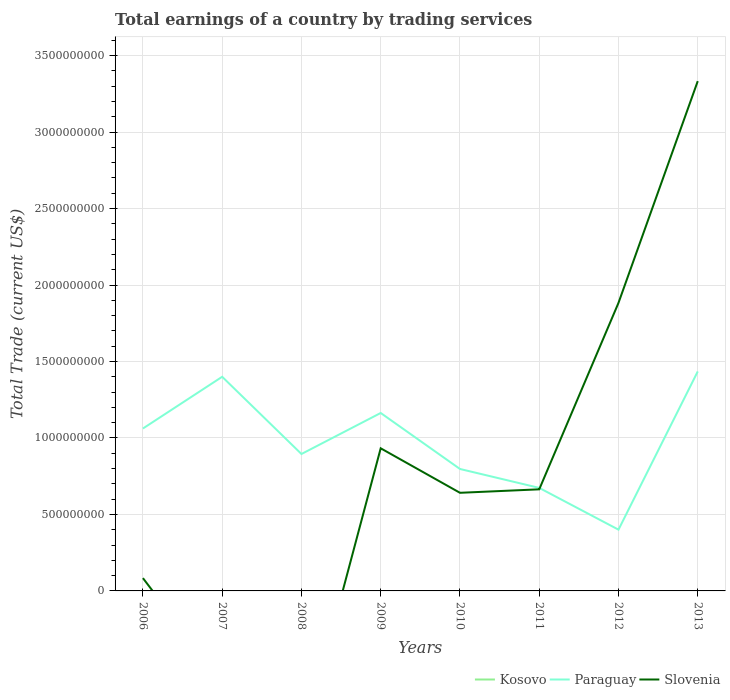Is the number of lines equal to the number of legend labels?
Your answer should be very brief. No. Across all years, what is the maximum total earnings in Kosovo?
Make the answer very short. 0. What is the total total earnings in Paraguay in the graph?
Your answer should be very brief. 6.61e+08. What is the difference between the highest and the second highest total earnings in Paraguay?
Provide a short and direct response. 1.03e+09. How many lines are there?
Make the answer very short. 2. How many years are there in the graph?
Make the answer very short. 8. What is the difference between two consecutive major ticks on the Y-axis?
Your answer should be compact. 5.00e+08. Are the values on the major ticks of Y-axis written in scientific E-notation?
Keep it short and to the point. No. Does the graph contain any zero values?
Make the answer very short. Yes. Does the graph contain grids?
Your answer should be very brief. Yes. Where does the legend appear in the graph?
Provide a short and direct response. Bottom right. What is the title of the graph?
Keep it short and to the point. Total earnings of a country by trading services. Does "Pakistan" appear as one of the legend labels in the graph?
Your answer should be compact. No. What is the label or title of the X-axis?
Provide a short and direct response. Years. What is the label or title of the Y-axis?
Ensure brevity in your answer.  Total Trade (current US$). What is the Total Trade (current US$) in Kosovo in 2006?
Offer a very short reply. 0. What is the Total Trade (current US$) in Paraguay in 2006?
Ensure brevity in your answer.  1.06e+09. What is the Total Trade (current US$) of Slovenia in 2006?
Give a very brief answer. 8.38e+07. What is the Total Trade (current US$) of Paraguay in 2007?
Offer a very short reply. 1.40e+09. What is the Total Trade (current US$) of Slovenia in 2007?
Ensure brevity in your answer.  0. What is the Total Trade (current US$) of Paraguay in 2008?
Your answer should be compact. 8.95e+08. What is the Total Trade (current US$) of Slovenia in 2008?
Provide a succinct answer. 0. What is the Total Trade (current US$) in Kosovo in 2009?
Provide a succinct answer. 0. What is the Total Trade (current US$) of Paraguay in 2009?
Provide a short and direct response. 1.16e+09. What is the Total Trade (current US$) in Slovenia in 2009?
Make the answer very short. 9.32e+08. What is the Total Trade (current US$) of Paraguay in 2010?
Offer a very short reply. 7.97e+08. What is the Total Trade (current US$) of Slovenia in 2010?
Your answer should be compact. 6.42e+08. What is the Total Trade (current US$) of Kosovo in 2011?
Keep it short and to the point. 0. What is the Total Trade (current US$) in Paraguay in 2011?
Provide a short and direct response. 6.74e+08. What is the Total Trade (current US$) of Slovenia in 2011?
Keep it short and to the point. 6.64e+08. What is the Total Trade (current US$) of Paraguay in 2012?
Your response must be concise. 4.01e+08. What is the Total Trade (current US$) of Slovenia in 2012?
Provide a short and direct response. 1.88e+09. What is the Total Trade (current US$) of Kosovo in 2013?
Provide a short and direct response. 0. What is the Total Trade (current US$) in Paraguay in 2013?
Provide a short and direct response. 1.43e+09. What is the Total Trade (current US$) of Slovenia in 2013?
Provide a succinct answer. 3.33e+09. Across all years, what is the maximum Total Trade (current US$) of Paraguay?
Your answer should be compact. 1.43e+09. Across all years, what is the maximum Total Trade (current US$) in Slovenia?
Keep it short and to the point. 3.33e+09. Across all years, what is the minimum Total Trade (current US$) in Paraguay?
Your response must be concise. 4.01e+08. Across all years, what is the minimum Total Trade (current US$) of Slovenia?
Provide a short and direct response. 0. What is the total Total Trade (current US$) of Paraguay in the graph?
Provide a succinct answer. 7.83e+09. What is the total Total Trade (current US$) in Slovenia in the graph?
Make the answer very short. 7.54e+09. What is the difference between the Total Trade (current US$) in Paraguay in 2006 and that in 2007?
Keep it short and to the point. -3.38e+08. What is the difference between the Total Trade (current US$) in Paraguay in 2006 and that in 2008?
Offer a terse response. 1.67e+08. What is the difference between the Total Trade (current US$) of Paraguay in 2006 and that in 2009?
Your answer should be compact. -1.02e+08. What is the difference between the Total Trade (current US$) of Slovenia in 2006 and that in 2009?
Provide a short and direct response. -8.49e+08. What is the difference between the Total Trade (current US$) of Paraguay in 2006 and that in 2010?
Your answer should be very brief. 2.65e+08. What is the difference between the Total Trade (current US$) of Slovenia in 2006 and that in 2010?
Your answer should be very brief. -5.58e+08. What is the difference between the Total Trade (current US$) in Paraguay in 2006 and that in 2011?
Provide a succinct answer. 3.88e+08. What is the difference between the Total Trade (current US$) in Slovenia in 2006 and that in 2011?
Keep it short and to the point. -5.80e+08. What is the difference between the Total Trade (current US$) in Paraguay in 2006 and that in 2012?
Your answer should be very brief. 6.61e+08. What is the difference between the Total Trade (current US$) of Slovenia in 2006 and that in 2012?
Ensure brevity in your answer.  -1.80e+09. What is the difference between the Total Trade (current US$) in Paraguay in 2006 and that in 2013?
Your response must be concise. -3.73e+08. What is the difference between the Total Trade (current US$) in Slovenia in 2006 and that in 2013?
Your answer should be very brief. -3.25e+09. What is the difference between the Total Trade (current US$) in Paraguay in 2007 and that in 2008?
Provide a short and direct response. 5.05e+08. What is the difference between the Total Trade (current US$) in Paraguay in 2007 and that in 2009?
Offer a very short reply. 2.37e+08. What is the difference between the Total Trade (current US$) of Paraguay in 2007 and that in 2010?
Keep it short and to the point. 6.03e+08. What is the difference between the Total Trade (current US$) in Paraguay in 2007 and that in 2011?
Your answer should be compact. 7.26e+08. What is the difference between the Total Trade (current US$) in Paraguay in 2007 and that in 2012?
Give a very brief answer. 1.00e+09. What is the difference between the Total Trade (current US$) in Paraguay in 2007 and that in 2013?
Provide a short and direct response. -3.49e+07. What is the difference between the Total Trade (current US$) of Paraguay in 2008 and that in 2009?
Your answer should be very brief. -2.68e+08. What is the difference between the Total Trade (current US$) of Paraguay in 2008 and that in 2010?
Give a very brief answer. 9.79e+07. What is the difference between the Total Trade (current US$) of Paraguay in 2008 and that in 2011?
Make the answer very short. 2.22e+08. What is the difference between the Total Trade (current US$) of Paraguay in 2008 and that in 2012?
Provide a short and direct response. 4.95e+08. What is the difference between the Total Trade (current US$) of Paraguay in 2008 and that in 2013?
Offer a very short reply. -5.40e+08. What is the difference between the Total Trade (current US$) of Paraguay in 2009 and that in 2010?
Offer a terse response. 3.66e+08. What is the difference between the Total Trade (current US$) in Slovenia in 2009 and that in 2010?
Provide a succinct answer. 2.91e+08. What is the difference between the Total Trade (current US$) of Paraguay in 2009 and that in 2011?
Your answer should be very brief. 4.90e+08. What is the difference between the Total Trade (current US$) in Slovenia in 2009 and that in 2011?
Provide a short and direct response. 2.68e+08. What is the difference between the Total Trade (current US$) in Paraguay in 2009 and that in 2012?
Give a very brief answer. 7.63e+08. What is the difference between the Total Trade (current US$) of Slovenia in 2009 and that in 2012?
Your response must be concise. -9.51e+08. What is the difference between the Total Trade (current US$) in Paraguay in 2009 and that in 2013?
Offer a terse response. -2.72e+08. What is the difference between the Total Trade (current US$) of Slovenia in 2009 and that in 2013?
Make the answer very short. -2.40e+09. What is the difference between the Total Trade (current US$) in Paraguay in 2010 and that in 2011?
Provide a short and direct response. 1.24e+08. What is the difference between the Total Trade (current US$) of Slovenia in 2010 and that in 2011?
Offer a very short reply. -2.27e+07. What is the difference between the Total Trade (current US$) of Paraguay in 2010 and that in 2012?
Your answer should be very brief. 3.97e+08. What is the difference between the Total Trade (current US$) of Slovenia in 2010 and that in 2012?
Provide a succinct answer. -1.24e+09. What is the difference between the Total Trade (current US$) of Paraguay in 2010 and that in 2013?
Your response must be concise. -6.38e+08. What is the difference between the Total Trade (current US$) in Slovenia in 2010 and that in 2013?
Provide a short and direct response. -2.69e+09. What is the difference between the Total Trade (current US$) in Paraguay in 2011 and that in 2012?
Offer a terse response. 2.73e+08. What is the difference between the Total Trade (current US$) in Slovenia in 2011 and that in 2012?
Your answer should be compact. -1.22e+09. What is the difference between the Total Trade (current US$) in Paraguay in 2011 and that in 2013?
Keep it short and to the point. -7.61e+08. What is the difference between the Total Trade (current US$) in Slovenia in 2011 and that in 2013?
Make the answer very short. -2.67e+09. What is the difference between the Total Trade (current US$) of Paraguay in 2012 and that in 2013?
Make the answer very short. -1.03e+09. What is the difference between the Total Trade (current US$) in Slovenia in 2012 and that in 2013?
Your answer should be compact. -1.45e+09. What is the difference between the Total Trade (current US$) in Paraguay in 2006 and the Total Trade (current US$) in Slovenia in 2009?
Your answer should be very brief. 1.29e+08. What is the difference between the Total Trade (current US$) in Paraguay in 2006 and the Total Trade (current US$) in Slovenia in 2010?
Your answer should be compact. 4.20e+08. What is the difference between the Total Trade (current US$) of Paraguay in 2006 and the Total Trade (current US$) of Slovenia in 2011?
Keep it short and to the point. 3.98e+08. What is the difference between the Total Trade (current US$) in Paraguay in 2006 and the Total Trade (current US$) in Slovenia in 2012?
Offer a very short reply. -8.22e+08. What is the difference between the Total Trade (current US$) of Paraguay in 2006 and the Total Trade (current US$) of Slovenia in 2013?
Offer a very short reply. -2.27e+09. What is the difference between the Total Trade (current US$) in Paraguay in 2007 and the Total Trade (current US$) in Slovenia in 2009?
Your response must be concise. 4.68e+08. What is the difference between the Total Trade (current US$) of Paraguay in 2007 and the Total Trade (current US$) of Slovenia in 2010?
Offer a terse response. 7.59e+08. What is the difference between the Total Trade (current US$) in Paraguay in 2007 and the Total Trade (current US$) in Slovenia in 2011?
Ensure brevity in your answer.  7.36e+08. What is the difference between the Total Trade (current US$) of Paraguay in 2007 and the Total Trade (current US$) of Slovenia in 2012?
Make the answer very short. -4.83e+08. What is the difference between the Total Trade (current US$) of Paraguay in 2007 and the Total Trade (current US$) of Slovenia in 2013?
Offer a terse response. -1.93e+09. What is the difference between the Total Trade (current US$) of Paraguay in 2008 and the Total Trade (current US$) of Slovenia in 2009?
Provide a short and direct response. -3.73e+07. What is the difference between the Total Trade (current US$) in Paraguay in 2008 and the Total Trade (current US$) in Slovenia in 2010?
Give a very brief answer. 2.54e+08. What is the difference between the Total Trade (current US$) of Paraguay in 2008 and the Total Trade (current US$) of Slovenia in 2011?
Offer a terse response. 2.31e+08. What is the difference between the Total Trade (current US$) in Paraguay in 2008 and the Total Trade (current US$) in Slovenia in 2012?
Offer a very short reply. -9.88e+08. What is the difference between the Total Trade (current US$) of Paraguay in 2008 and the Total Trade (current US$) of Slovenia in 2013?
Make the answer very short. -2.44e+09. What is the difference between the Total Trade (current US$) of Paraguay in 2009 and the Total Trade (current US$) of Slovenia in 2010?
Provide a short and direct response. 5.22e+08. What is the difference between the Total Trade (current US$) of Paraguay in 2009 and the Total Trade (current US$) of Slovenia in 2011?
Your answer should be very brief. 4.99e+08. What is the difference between the Total Trade (current US$) of Paraguay in 2009 and the Total Trade (current US$) of Slovenia in 2012?
Offer a very short reply. -7.20e+08. What is the difference between the Total Trade (current US$) of Paraguay in 2009 and the Total Trade (current US$) of Slovenia in 2013?
Offer a very short reply. -2.17e+09. What is the difference between the Total Trade (current US$) of Paraguay in 2010 and the Total Trade (current US$) of Slovenia in 2011?
Offer a very short reply. 1.33e+08. What is the difference between the Total Trade (current US$) in Paraguay in 2010 and the Total Trade (current US$) in Slovenia in 2012?
Provide a short and direct response. -1.09e+09. What is the difference between the Total Trade (current US$) in Paraguay in 2010 and the Total Trade (current US$) in Slovenia in 2013?
Provide a short and direct response. -2.54e+09. What is the difference between the Total Trade (current US$) in Paraguay in 2011 and the Total Trade (current US$) in Slovenia in 2012?
Your response must be concise. -1.21e+09. What is the difference between the Total Trade (current US$) of Paraguay in 2011 and the Total Trade (current US$) of Slovenia in 2013?
Provide a succinct answer. -2.66e+09. What is the difference between the Total Trade (current US$) of Paraguay in 2012 and the Total Trade (current US$) of Slovenia in 2013?
Keep it short and to the point. -2.93e+09. What is the average Total Trade (current US$) of Kosovo per year?
Make the answer very short. 0. What is the average Total Trade (current US$) in Paraguay per year?
Your answer should be compact. 9.78e+08. What is the average Total Trade (current US$) in Slovenia per year?
Offer a terse response. 9.42e+08. In the year 2006, what is the difference between the Total Trade (current US$) of Paraguay and Total Trade (current US$) of Slovenia?
Provide a short and direct response. 9.78e+08. In the year 2009, what is the difference between the Total Trade (current US$) of Paraguay and Total Trade (current US$) of Slovenia?
Ensure brevity in your answer.  2.31e+08. In the year 2010, what is the difference between the Total Trade (current US$) in Paraguay and Total Trade (current US$) in Slovenia?
Your answer should be very brief. 1.56e+08. In the year 2011, what is the difference between the Total Trade (current US$) of Paraguay and Total Trade (current US$) of Slovenia?
Your answer should be compact. 9.43e+06. In the year 2012, what is the difference between the Total Trade (current US$) of Paraguay and Total Trade (current US$) of Slovenia?
Ensure brevity in your answer.  -1.48e+09. In the year 2013, what is the difference between the Total Trade (current US$) in Paraguay and Total Trade (current US$) in Slovenia?
Give a very brief answer. -1.90e+09. What is the ratio of the Total Trade (current US$) of Paraguay in 2006 to that in 2007?
Provide a succinct answer. 0.76. What is the ratio of the Total Trade (current US$) in Paraguay in 2006 to that in 2008?
Give a very brief answer. 1.19. What is the ratio of the Total Trade (current US$) in Paraguay in 2006 to that in 2009?
Offer a terse response. 0.91. What is the ratio of the Total Trade (current US$) in Slovenia in 2006 to that in 2009?
Your answer should be compact. 0.09. What is the ratio of the Total Trade (current US$) in Paraguay in 2006 to that in 2010?
Your answer should be compact. 1.33. What is the ratio of the Total Trade (current US$) of Slovenia in 2006 to that in 2010?
Your answer should be compact. 0.13. What is the ratio of the Total Trade (current US$) of Paraguay in 2006 to that in 2011?
Make the answer very short. 1.58. What is the ratio of the Total Trade (current US$) of Slovenia in 2006 to that in 2011?
Your answer should be very brief. 0.13. What is the ratio of the Total Trade (current US$) of Paraguay in 2006 to that in 2012?
Keep it short and to the point. 2.65. What is the ratio of the Total Trade (current US$) of Slovenia in 2006 to that in 2012?
Provide a succinct answer. 0.04. What is the ratio of the Total Trade (current US$) of Paraguay in 2006 to that in 2013?
Provide a succinct answer. 0.74. What is the ratio of the Total Trade (current US$) of Slovenia in 2006 to that in 2013?
Offer a very short reply. 0.03. What is the ratio of the Total Trade (current US$) in Paraguay in 2007 to that in 2008?
Your answer should be very brief. 1.56. What is the ratio of the Total Trade (current US$) in Paraguay in 2007 to that in 2009?
Offer a very short reply. 1.2. What is the ratio of the Total Trade (current US$) in Paraguay in 2007 to that in 2010?
Ensure brevity in your answer.  1.76. What is the ratio of the Total Trade (current US$) of Paraguay in 2007 to that in 2011?
Make the answer very short. 2.08. What is the ratio of the Total Trade (current US$) in Paraguay in 2007 to that in 2012?
Your answer should be very brief. 3.5. What is the ratio of the Total Trade (current US$) of Paraguay in 2007 to that in 2013?
Give a very brief answer. 0.98. What is the ratio of the Total Trade (current US$) in Paraguay in 2008 to that in 2009?
Offer a very short reply. 0.77. What is the ratio of the Total Trade (current US$) in Paraguay in 2008 to that in 2010?
Make the answer very short. 1.12. What is the ratio of the Total Trade (current US$) of Paraguay in 2008 to that in 2011?
Ensure brevity in your answer.  1.33. What is the ratio of the Total Trade (current US$) of Paraguay in 2008 to that in 2012?
Offer a terse response. 2.23. What is the ratio of the Total Trade (current US$) in Paraguay in 2008 to that in 2013?
Your response must be concise. 0.62. What is the ratio of the Total Trade (current US$) of Paraguay in 2009 to that in 2010?
Offer a terse response. 1.46. What is the ratio of the Total Trade (current US$) of Slovenia in 2009 to that in 2010?
Your response must be concise. 1.45. What is the ratio of the Total Trade (current US$) of Paraguay in 2009 to that in 2011?
Your response must be concise. 1.73. What is the ratio of the Total Trade (current US$) in Slovenia in 2009 to that in 2011?
Ensure brevity in your answer.  1.4. What is the ratio of the Total Trade (current US$) in Paraguay in 2009 to that in 2012?
Provide a short and direct response. 2.9. What is the ratio of the Total Trade (current US$) in Slovenia in 2009 to that in 2012?
Offer a very short reply. 0.5. What is the ratio of the Total Trade (current US$) in Paraguay in 2009 to that in 2013?
Provide a succinct answer. 0.81. What is the ratio of the Total Trade (current US$) of Slovenia in 2009 to that in 2013?
Offer a very short reply. 0.28. What is the ratio of the Total Trade (current US$) in Paraguay in 2010 to that in 2011?
Keep it short and to the point. 1.18. What is the ratio of the Total Trade (current US$) in Slovenia in 2010 to that in 2011?
Your answer should be compact. 0.97. What is the ratio of the Total Trade (current US$) of Paraguay in 2010 to that in 2012?
Keep it short and to the point. 1.99. What is the ratio of the Total Trade (current US$) in Slovenia in 2010 to that in 2012?
Your answer should be very brief. 0.34. What is the ratio of the Total Trade (current US$) in Paraguay in 2010 to that in 2013?
Offer a very short reply. 0.56. What is the ratio of the Total Trade (current US$) in Slovenia in 2010 to that in 2013?
Make the answer very short. 0.19. What is the ratio of the Total Trade (current US$) of Paraguay in 2011 to that in 2012?
Keep it short and to the point. 1.68. What is the ratio of the Total Trade (current US$) in Slovenia in 2011 to that in 2012?
Your answer should be very brief. 0.35. What is the ratio of the Total Trade (current US$) in Paraguay in 2011 to that in 2013?
Make the answer very short. 0.47. What is the ratio of the Total Trade (current US$) in Slovenia in 2011 to that in 2013?
Give a very brief answer. 0.2. What is the ratio of the Total Trade (current US$) in Paraguay in 2012 to that in 2013?
Provide a succinct answer. 0.28. What is the ratio of the Total Trade (current US$) in Slovenia in 2012 to that in 2013?
Your answer should be very brief. 0.57. What is the difference between the highest and the second highest Total Trade (current US$) of Paraguay?
Your answer should be compact. 3.49e+07. What is the difference between the highest and the second highest Total Trade (current US$) in Slovenia?
Keep it short and to the point. 1.45e+09. What is the difference between the highest and the lowest Total Trade (current US$) in Paraguay?
Your answer should be very brief. 1.03e+09. What is the difference between the highest and the lowest Total Trade (current US$) in Slovenia?
Your answer should be compact. 3.33e+09. 